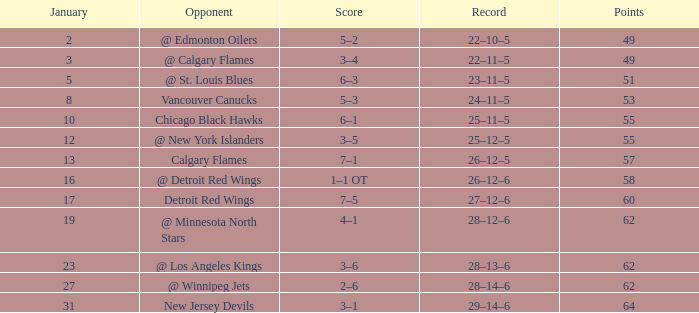How many Games have a Score of 2–6, and Points larger than 62? 0.0. Could you help me parse every detail presented in this table? {'header': ['January', 'Opponent', 'Score', 'Record', 'Points'], 'rows': [['2', '@ Edmonton Oilers', '5–2', '22–10–5', '49'], ['3', '@ Calgary Flames', '3–4', '22–11–5', '49'], ['5', '@ St. Louis Blues', '6–3', '23–11–5', '51'], ['8', 'Vancouver Canucks', '5–3', '24–11–5', '53'], ['10', 'Chicago Black Hawks', '6–1', '25–11–5', '55'], ['12', '@ New York Islanders', '3–5', '25–12–5', '55'], ['13', 'Calgary Flames', '7–1', '26–12–5', '57'], ['16', '@ Detroit Red Wings', '1–1 OT', '26–12–6', '58'], ['17', 'Detroit Red Wings', '7–5', '27–12–6', '60'], ['19', '@ Minnesota North Stars', '4–1', '28–12–6', '62'], ['23', '@ Los Angeles Kings', '3–6', '28–13–6', '62'], ['27', '@ Winnipeg Jets', '2–6', '28–14–6', '62'], ['31', 'New Jersey Devils', '3–1', '29–14–6', '64']]} 